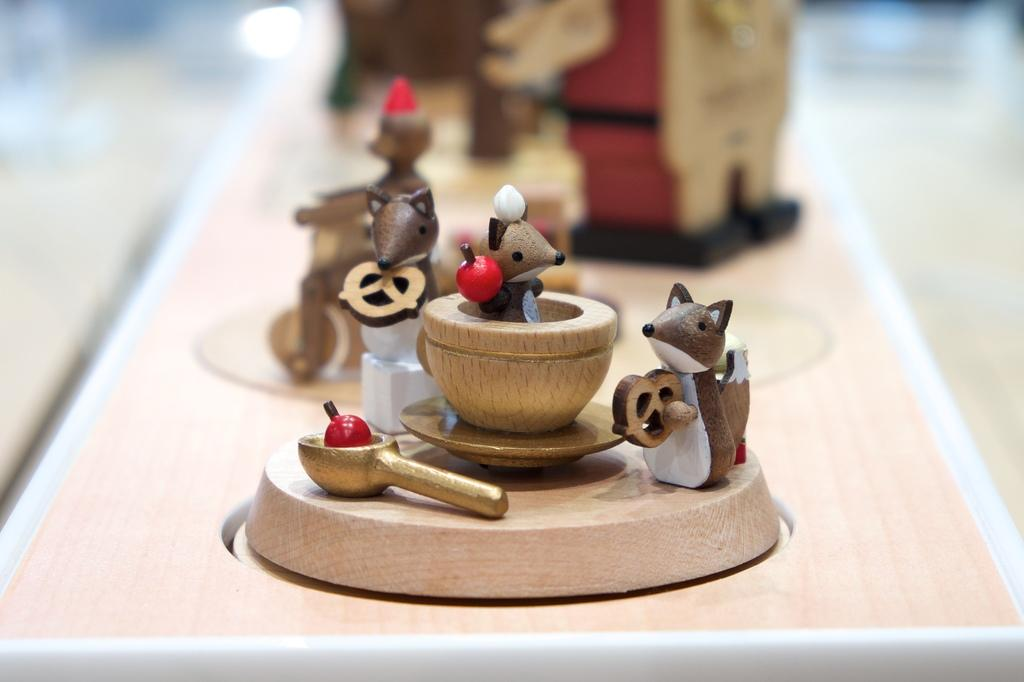What objects can be seen on the table in the image? There are toys on the table in the image. Can you describe one of the toys on the table? There is a mouse toy on the table. What type of club can be seen in the image? There is no club present in the image; it features toys on a table, including a mouse toy. 